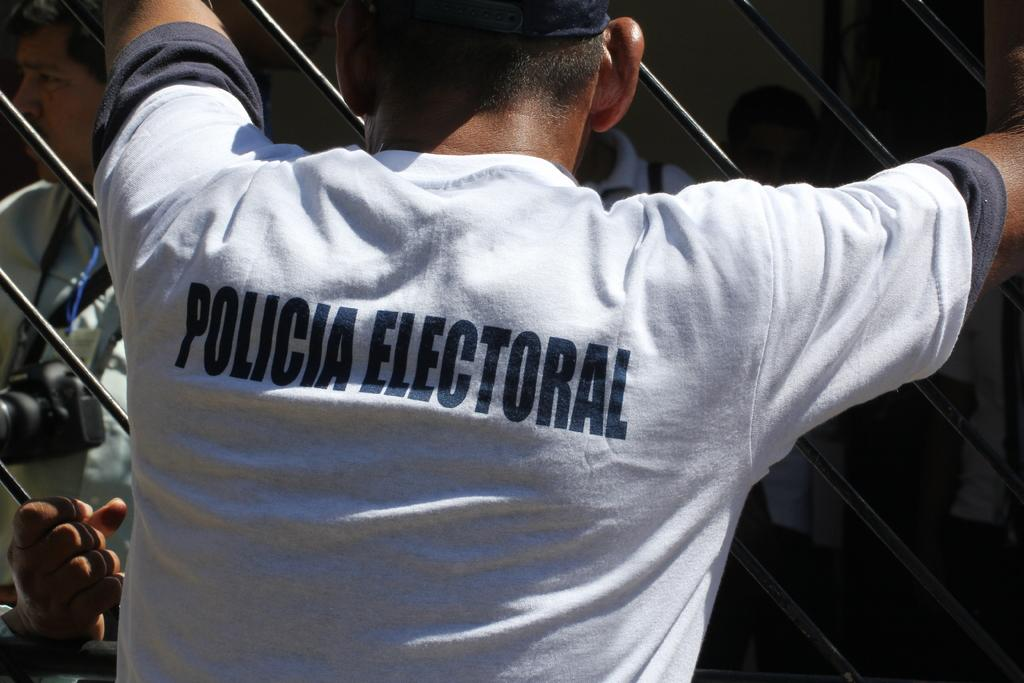<image>
Summarize the visual content of the image. A man wearing a white shirt that says Policia Electoral on the back is leaning on a gate, facing other people in the stands of a game. 